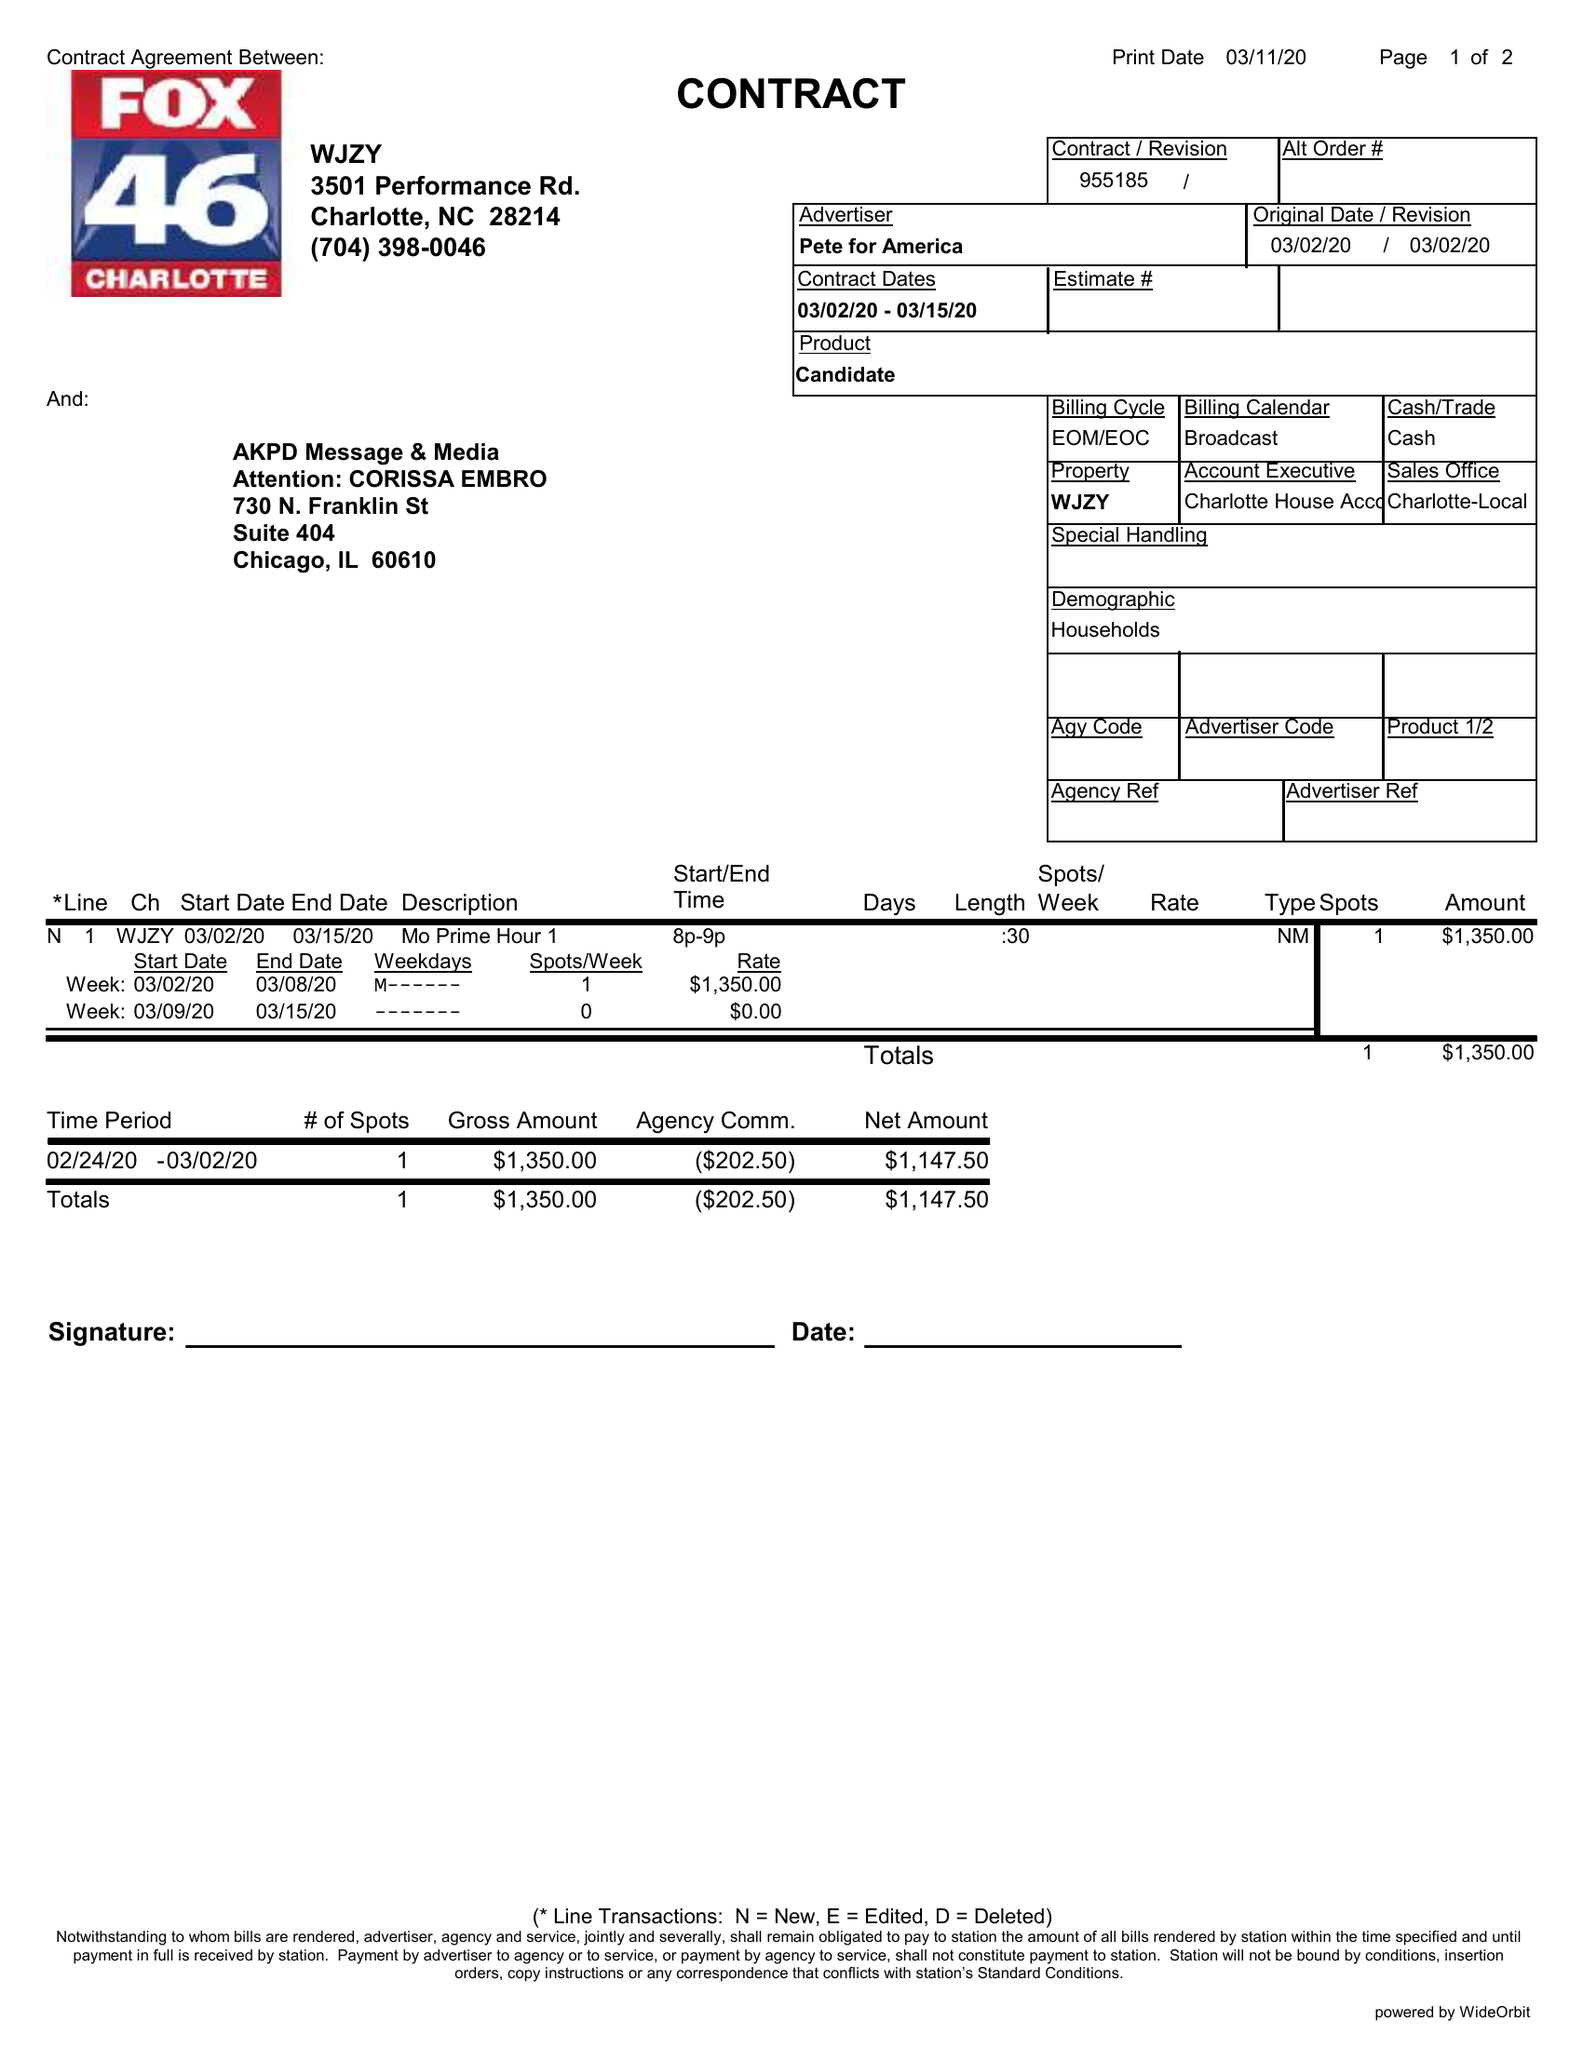What is the value for the gross_amount?
Answer the question using a single word or phrase. 1350.00 